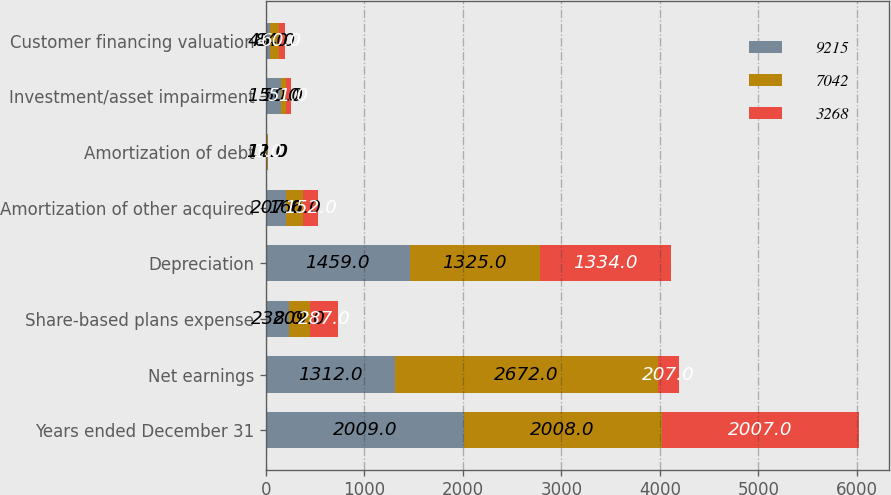<chart> <loc_0><loc_0><loc_500><loc_500><stacked_bar_chart><ecel><fcel>Years ended December 31<fcel>Net earnings<fcel>Share-based plans expense<fcel>Depreciation<fcel>Amortization of other acquired<fcel>Amortization of debt<fcel>Investment/asset impairment<fcel>Customer financing valuation<nl><fcel>9215<fcel>2009<fcel>1312<fcel>238<fcel>1459<fcel>207<fcel>12<fcel>151<fcel>45<nl><fcel>7042<fcel>2008<fcel>2672<fcel>209<fcel>1325<fcel>166<fcel>11<fcel>50<fcel>84<nl><fcel>3268<fcel>2007<fcel>207<fcel>287<fcel>1334<fcel>152<fcel>1<fcel>51<fcel>60<nl></chart> 